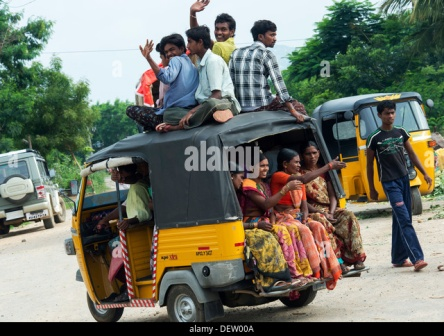Imagine a story unfolding that led to this moment captured in the image. Earlier that day, this group of friends decided to explore a nearby festival in the village. Packed into the auto rickshaw, the initial journey was filled with laughter and anticipation. Upon reaching the festival, they enjoyed various traditional games, food, and performances, which heightened their spirits. On their way back, still brimming with energy, some chose to sit on the roof of the rickshaw, turning a simple ride home into an impromptu celebration. Their joy and camaraderie caught the attention of bystanders, turning heads and drawing smiles from everyone along the way. 